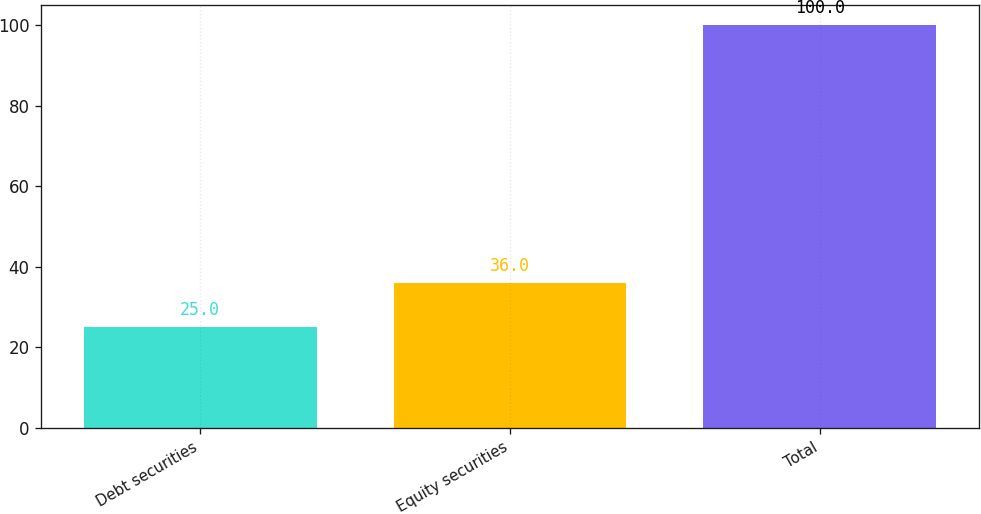Convert chart. <chart><loc_0><loc_0><loc_500><loc_500><bar_chart><fcel>Debt securities<fcel>Equity securities<fcel>Total<nl><fcel>25<fcel>36<fcel>100<nl></chart> 